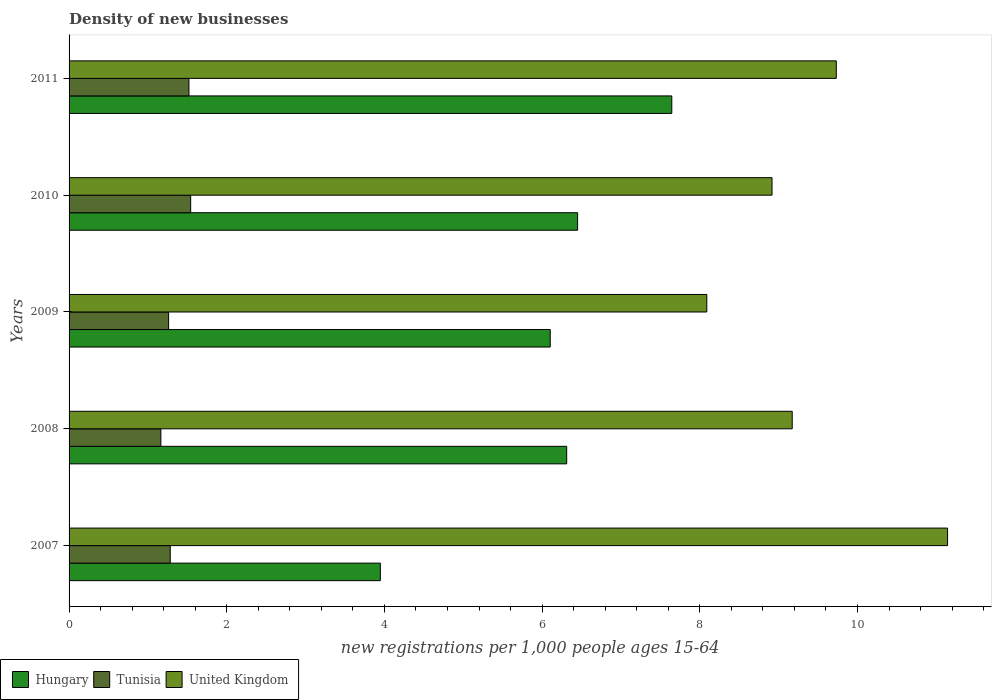How many groups of bars are there?
Provide a short and direct response. 5. Are the number of bars per tick equal to the number of legend labels?
Give a very brief answer. Yes. What is the number of new registrations in Tunisia in 2007?
Give a very brief answer. 1.28. Across all years, what is the maximum number of new registrations in United Kingdom?
Your response must be concise. 11.14. Across all years, what is the minimum number of new registrations in United Kingdom?
Ensure brevity in your answer.  8.09. In which year was the number of new registrations in Hungary maximum?
Give a very brief answer. 2011. In which year was the number of new registrations in Hungary minimum?
Keep it short and to the point. 2007. What is the total number of new registrations in Tunisia in the graph?
Make the answer very short. 6.77. What is the difference between the number of new registrations in Hungary in 2007 and that in 2010?
Offer a very short reply. -2.5. What is the difference between the number of new registrations in Hungary in 2009 and the number of new registrations in United Kingdom in 2007?
Give a very brief answer. -5.04. What is the average number of new registrations in Hungary per year?
Keep it short and to the point. 6.09. In the year 2010, what is the difference between the number of new registrations in Hungary and number of new registrations in Tunisia?
Offer a very short reply. 4.91. What is the ratio of the number of new registrations in United Kingdom in 2007 to that in 2009?
Your response must be concise. 1.38. What is the difference between the highest and the second highest number of new registrations in Hungary?
Make the answer very short. 1.19. What is the difference between the highest and the lowest number of new registrations in Tunisia?
Your answer should be very brief. 0.38. In how many years, is the number of new registrations in Hungary greater than the average number of new registrations in Hungary taken over all years?
Provide a succinct answer. 4. Is the sum of the number of new registrations in United Kingdom in 2008 and 2009 greater than the maximum number of new registrations in Hungary across all years?
Your response must be concise. Yes. What does the 1st bar from the top in 2008 represents?
Offer a terse response. United Kingdom. What does the 3rd bar from the bottom in 2007 represents?
Your response must be concise. United Kingdom. How many bars are there?
Keep it short and to the point. 15. How many years are there in the graph?
Provide a succinct answer. 5. Are the values on the major ticks of X-axis written in scientific E-notation?
Offer a terse response. No. Does the graph contain any zero values?
Your response must be concise. No. How are the legend labels stacked?
Provide a succinct answer. Horizontal. What is the title of the graph?
Make the answer very short. Density of new businesses. What is the label or title of the X-axis?
Your answer should be very brief. New registrations per 1,0 people ages 15-64. What is the label or title of the Y-axis?
Give a very brief answer. Years. What is the new registrations per 1,000 people ages 15-64 of Hungary in 2007?
Provide a succinct answer. 3.95. What is the new registrations per 1,000 people ages 15-64 of Tunisia in 2007?
Keep it short and to the point. 1.28. What is the new registrations per 1,000 people ages 15-64 of United Kingdom in 2007?
Make the answer very short. 11.14. What is the new registrations per 1,000 people ages 15-64 of Hungary in 2008?
Offer a terse response. 6.31. What is the new registrations per 1,000 people ages 15-64 in Tunisia in 2008?
Offer a very short reply. 1.16. What is the new registrations per 1,000 people ages 15-64 of United Kingdom in 2008?
Offer a terse response. 9.17. What is the new registrations per 1,000 people ages 15-64 in Hungary in 2009?
Offer a terse response. 6.1. What is the new registrations per 1,000 people ages 15-64 in Tunisia in 2009?
Your answer should be very brief. 1.26. What is the new registrations per 1,000 people ages 15-64 of United Kingdom in 2009?
Offer a terse response. 8.09. What is the new registrations per 1,000 people ages 15-64 in Hungary in 2010?
Provide a short and direct response. 6.45. What is the new registrations per 1,000 people ages 15-64 of Tunisia in 2010?
Provide a succinct answer. 1.54. What is the new registrations per 1,000 people ages 15-64 of United Kingdom in 2010?
Provide a short and direct response. 8.92. What is the new registrations per 1,000 people ages 15-64 of Hungary in 2011?
Give a very brief answer. 7.64. What is the new registrations per 1,000 people ages 15-64 of Tunisia in 2011?
Your response must be concise. 1.52. What is the new registrations per 1,000 people ages 15-64 of United Kingdom in 2011?
Provide a succinct answer. 9.73. Across all years, what is the maximum new registrations per 1,000 people ages 15-64 in Hungary?
Your answer should be very brief. 7.64. Across all years, what is the maximum new registrations per 1,000 people ages 15-64 of Tunisia?
Ensure brevity in your answer.  1.54. Across all years, what is the maximum new registrations per 1,000 people ages 15-64 of United Kingdom?
Your answer should be compact. 11.14. Across all years, what is the minimum new registrations per 1,000 people ages 15-64 in Hungary?
Your response must be concise. 3.95. Across all years, what is the minimum new registrations per 1,000 people ages 15-64 in Tunisia?
Offer a terse response. 1.16. Across all years, what is the minimum new registrations per 1,000 people ages 15-64 in United Kingdom?
Your answer should be compact. 8.09. What is the total new registrations per 1,000 people ages 15-64 of Hungary in the graph?
Keep it short and to the point. 30.46. What is the total new registrations per 1,000 people ages 15-64 of Tunisia in the graph?
Your answer should be compact. 6.77. What is the total new registrations per 1,000 people ages 15-64 of United Kingdom in the graph?
Provide a succinct answer. 47.05. What is the difference between the new registrations per 1,000 people ages 15-64 of Hungary in 2007 and that in 2008?
Your answer should be compact. -2.36. What is the difference between the new registrations per 1,000 people ages 15-64 in Tunisia in 2007 and that in 2008?
Your response must be concise. 0.12. What is the difference between the new registrations per 1,000 people ages 15-64 in United Kingdom in 2007 and that in 2008?
Keep it short and to the point. 1.97. What is the difference between the new registrations per 1,000 people ages 15-64 in Hungary in 2007 and that in 2009?
Your response must be concise. -2.15. What is the difference between the new registrations per 1,000 people ages 15-64 of Tunisia in 2007 and that in 2009?
Provide a succinct answer. 0.02. What is the difference between the new registrations per 1,000 people ages 15-64 in United Kingdom in 2007 and that in 2009?
Make the answer very short. 3.05. What is the difference between the new registrations per 1,000 people ages 15-64 in Hungary in 2007 and that in 2010?
Your answer should be very brief. -2.5. What is the difference between the new registrations per 1,000 people ages 15-64 of Tunisia in 2007 and that in 2010?
Provide a succinct answer. -0.26. What is the difference between the new registrations per 1,000 people ages 15-64 in United Kingdom in 2007 and that in 2010?
Ensure brevity in your answer.  2.23. What is the difference between the new registrations per 1,000 people ages 15-64 of Hungary in 2007 and that in 2011?
Ensure brevity in your answer.  -3.7. What is the difference between the new registrations per 1,000 people ages 15-64 of Tunisia in 2007 and that in 2011?
Your answer should be compact. -0.24. What is the difference between the new registrations per 1,000 people ages 15-64 of United Kingdom in 2007 and that in 2011?
Make the answer very short. 1.41. What is the difference between the new registrations per 1,000 people ages 15-64 in Hungary in 2008 and that in 2009?
Offer a terse response. 0.21. What is the difference between the new registrations per 1,000 people ages 15-64 in Tunisia in 2008 and that in 2009?
Provide a short and direct response. -0.1. What is the difference between the new registrations per 1,000 people ages 15-64 of United Kingdom in 2008 and that in 2009?
Give a very brief answer. 1.08. What is the difference between the new registrations per 1,000 people ages 15-64 of Hungary in 2008 and that in 2010?
Give a very brief answer. -0.14. What is the difference between the new registrations per 1,000 people ages 15-64 in Tunisia in 2008 and that in 2010?
Make the answer very short. -0.38. What is the difference between the new registrations per 1,000 people ages 15-64 in United Kingdom in 2008 and that in 2010?
Give a very brief answer. 0.26. What is the difference between the new registrations per 1,000 people ages 15-64 of Hungary in 2008 and that in 2011?
Offer a very short reply. -1.33. What is the difference between the new registrations per 1,000 people ages 15-64 of Tunisia in 2008 and that in 2011?
Ensure brevity in your answer.  -0.36. What is the difference between the new registrations per 1,000 people ages 15-64 of United Kingdom in 2008 and that in 2011?
Provide a short and direct response. -0.56. What is the difference between the new registrations per 1,000 people ages 15-64 of Hungary in 2009 and that in 2010?
Offer a terse response. -0.35. What is the difference between the new registrations per 1,000 people ages 15-64 of Tunisia in 2009 and that in 2010?
Give a very brief answer. -0.28. What is the difference between the new registrations per 1,000 people ages 15-64 in United Kingdom in 2009 and that in 2010?
Make the answer very short. -0.83. What is the difference between the new registrations per 1,000 people ages 15-64 in Hungary in 2009 and that in 2011?
Ensure brevity in your answer.  -1.54. What is the difference between the new registrations per 1,000 people ages 15-64 in Tunisia in 2009 and that in 2011?
Provide a succinct answer. -0.26. What is the difference between the new registrations per 1,000 people ages 15-64 in United Kingdom in 2009 and that in 2011?
Provide a succinct answer. -1.64. What is the difference between the new registrations per 1,000 people ages 15-64 in Hungary in 2010 and that in 2011?
Provide a succinct answer. -1.19. What is the difference between the new registrations per 1,000 people ages 15-64 in Tunisia in 2010 and that in 2011?
Your answer should be very brief. 0.02. What is the difference between the new registrations per 1,000 people ages 15-64 in United Kingdom in 2010 and that in 2011?
Your answer should be very brief. -0.81. What is the difference between the new registrations per 1,000 people ages 15-64 in Hungary in 2007 and the new registrations per 1,000 people ages 15-64 in Tunisia in 2008?
Keep it short and to the point. 2.78. What is the difference between the new registrations per 1,000 people ages 15-64 of Hungary in 2007 and the new registrations per 1,000 people ages 15-64 of United Kingdom in 2008?
Your answer should be compact. -5.22. What is the difference between the new registrations per 1,000 people ages 15-64 in Tunisia in 2007 and the new registrations per 1,000 people ages 15-64 in United Kingdom in 2008?
Your response must be concise. -7.89. What is the difference between the new registrations per 1,000 people ages 15-64 of Hungary in 2007 and the new registrations per 1,000 people ages 15-64 of Tunisia in 2009?
Make the answer very short. 2.69. What is the difference between the new registrations per 1,000 people ages 15-64 of Hungary in 2007 and the new registrations per 1,000 people ages 15-64 of United Kingdom in 2009?
Provide a succinct answer. -4.14. What is the difference between the new registrations per 1,000 people ages 15-64 of Tunisia in 2007 and the new registrations per 1,000 people ages 15-64 of United Kingdom in 2009?
Make the answer very short. -6.81. What is the difference between the new registrations per 1,000 people ages 15-64 of Hungary in 2007 and the new registrations per 1,000 people ages 15-64 of Tunisia in 2010?
Your response must be concise. 2.41. What is the difference between the new registrations per 1,000 people ages 15-64 in Hungary in 2007 and the new registrations per 1,000 people ages 15-64 in United Kingdom in 2010?
Offer a terse response. -4.97. What is the difference between the new registrations per 1,000 people ages 15-64 of Tunisia in 2007 and the new registrations per 1,000 people ages 15-64 of United Kingdom in 2010?
Make the answer very short. -7.63. What is the difference between the new registrations per 1,000 people ages 15-64 of Hungary in 2007 and the new registrations per 1,000 people ages 15-64 of Tunisia in 2011?
Ensure brevity in your answer.  2.43. What is the difference between the new registrations per 1,000 people ages 15-64 in Hungary in 2007 and the new registrations per 1,000 people ages 15-64 in United Kingdom in 2011?
Provide a succinct answer. -5.78. What is the difference between the new registrations per 1,000 people ages 15-64 in Tunisia in 2007 and the new registrations per 1,000 people ages 15-64 in United Kingdom in 2011?
Offer a terse response. -8.45. What is the difference between the new registrations per 1,000 people ages 15-64 of Hungary in 2008 and the new registrations per 1,000 people ages 15-64 of Tunisia in 2009?
Your answer should be compact. 5.05. What is the difference between the new registrations per 1,000 people ages 15-64 in Hungary in 2008 and the new registrations per 1,000 people ages 15-64 in United Kingdom in 2009?
Offer a very short reply. -1.78. What is the difference between the new registrations per 1,000 people ages 15-64 in Tunisia in 2008 and the new registrations per 1,000 people ages 15-64 in United Kingdom in 2009?
Keep it short and to the point. -6.92. What is the difference between the new registrations per 1,000 people ages 15-64 of Hungary in 2008 and the new registrations per 1,000 people ages 15-64 of Tunisia in 2010?
Ensure brevity in your answer.  4.77. What is the difference between the new registrations per 1,000 people ages 15-64 in Hungary in 2008 and the new registrations per 1,000 people ages 15-64 in United Kingdom in 2010?
Offer a very short reply. -2.6. What is the difference between the new registrations per 1,000 people ages 15-64 of Tunisia in 2008 and the new registrations per 1,000 people ages 15-64 of United Kingdom in 2010?
Your answer should be very brief. -7.75. What is the difference between the new registrations per 1,000 people ages 15-64 in Hungary in 2008 and the new registrations per 1,000 people ages 15-64 in Tunisia in 2011?
Your answer should be very brief. 4.79. What is the difference between the new registrations per 1,000 people ages 15-64 in Hungary in 2008 and the new registrations per 1,000 people ages 15-64 in United Kingdom in 2011?
Your answer should be compact. -3.42. What is the difference between the new registrations per 1,000 people ages 15-64 of Tunisia in 2008 and the new registrations per 1,000 people ages 15-64 of United Kingdom in 2011?
Offer a very short reply. -8.57. What is the difference between the new registrations per 1,000 people ages 15-64 of Hungary in 2009 and the new registrations per 1,000 people ages 15-64 of Tunisia in 2010?
Give a very brief answer. 4.56. What is the difference between the new registrations per 1,000 people ages 15-64 in Hungary in 2009 and the new registrations per 1,000 people ages 15-64 in United Kingdom in 2010?
Keep it short and to the point. -2.81. What is the difference between the new registrations per 1,000 people ages 15-64 in Tunisia in 2009 and the new registrations per 1,000 people ages 15-64 in United Kingdom in 2010?
Provide a succinct answer. -7.65. What is the difference between the new registrations per 1,000 people ages 15-64 of Hungary in 2009 and the new registrations per 1,000 people ages 15-64 of Tunisia in 2011?
Keep it short and to the point. 4.58. What is the difference between the new registrations per 1,000 people ages 15-64 in Hungary in 2009 and the new registrations per 1,000 people ages 15-64 in United Kingdom in 2011?
Your response must be concise. -3.63. What is the difference between the new registrations per 1,000 people ages 15-64 in Tunisia in 2009 and the new registrations per 1,000 people ages 15-64 in United Kingdom in 2011?
Give a very brief answer. -8.47. What is the difference between the new registrations per 1,000 people ages 15-64 of Hungary in 2010 and the new registrations per 1,000 people ages 15-64 of Tunisia in 2011?
Ensure brevity in your answer.  4.93. What is the difference between the new registrations per 1,000 people ages 15-64 in Hungary in 2010 and the new registrations per 1,000 people ages 15-64 in United Kingdom in 2011?
Your answer should be very brief. -3.28. What is the difference between the new registrations per 1,000 people ages 15-64 in Tunisia in 2010 and the new registrations per 1,000 people ages 15-64 in United Kingdom in 2011?
Offer a very short reply. -8.19. What is the average new registrations per 1,000 people ages 15-64 in Hungary per year?
Keep it short and to the point. 6.09. What is the average new registrations per 1,000 people ages 15-64 of Tunisia per year?
Give a very brief answer. 1.35. What is the average new registrations per 1,000 people ages 15-64 of United Kingdom per year?
Your response must be concise. 9.41. In the year 2007, what is the difference between the new registrations per 1,000 people ages 15-64 of Hungary and new registrations per 1,000 people ages 15-64 of Tunisia?
Your answer should be very brief. 2.66. In the year 2007, what is the difference between the new registrations per 1,000 people ages 15-64 in Hungary and new registrations per 1,000 people ages 15-64 in United Kingdom?
Provide a short and direct response. -7.19. In the year 2007, what is the difference between the new registrations per 1,000 people ages 15-64 of Tunisia and new registrations per 1,000 people ages 15-64 of United Kingdom?
Your answer should be very brief. -9.86. In the year 2008, what is the difference between the new registrations per 1,000 people ages 15-64 in Hungary and new registrations per 1,000 people ages 15-64 in Tunisia?
Give a very brief answer. 5.15. In the year 2008, what is the difference between the new registrations per 1,000 people ages 15-64 of Hungary and new registrations per 1,000 people ages 15-64 of United Kingdom?
Your answer should be very brief. -2.86. In the year 2008, what is the difference between the new registrations per 1,000 people ages 15-64 in Tunisia and new registrations per 1,000 people ages 15-64 in United Kingdom?
Your answer should be compact. -8.01. In the year 2009, what is the difference between the new registrations per 1,000 people ages 15-64 of Hungary and new registrations per 1,000 people ages 15-64 of Tunisia?
Provide a succinct answer. 4.84. In the year 2009, what is the difference between the new registrations per 1,000 people ages 15-64 of Hungary and new registrations per 1,000 people ages 15-64 of United Kingdom?
Keep it short and to the point. -1.99. In the year 2009, what is the difference between the new registrations per 1,000 people ages 15-64 in Tunisia and new registrations per 1,000 people ages 15-64 in United Kingdom?
Ensure brevity in your answer.  -6.83. In the year 2010, what is the difference between the new registrations per 1,000 people ages 15-64 of Hungary and new registrations per 1,000 people ages 15-64 of Tunisia?
Provide a succinct answer. 4.91. In the year 2010, what is the difference between the new registrations per 1,000 people ages 15-64 in Hungary and new registrations per 1,000 people ages 15-64 in United Kingdom?
Your response must be concise. -2.47. In the year 2010, what is the difference between the new registrations per 1,000 people ages 15-64 in Tunisia and new registrations per 1,000 people ages 15-64 in United Kingdom?
Provide a short and direct response. -7.37. In the year 2011, what is the difference between the new registrations per 1,000 people ages 15-64 of Hungary and new registrations per 1,000 people ages 15-64 of Tunisia?
Your answer should be compact. 6.12. In the year 2011, what is the difference between the new registrations per 1,000 people ages 15-64 in Hungary and new registrations per 1,000 people ages 15-64 in United Kingdom?
Offer a terse response. -2.09. In the year 2011, what is the difference between the new registrations per 1,000 people ages 15-64 of Tunisia and new registrations per 1,000 people ages 15-64 of United Kingdom?
Make the answer very short. -8.21. What is the ratio of the new registrations per 1,000 people ages 15-64 of Hungary in 2007 to that in 2008?
Your answer should be very brief. 0.63. What is the ratio of the new registrations per 1,000 people ages 15-64 in Tunisia in 2007 to that in 2008?
Provide a succinct answer. 1.1. What is the ratio of the new registrations per 1,000 people ages 15-64 of United Kingdom in 2007 to that in 2008?
Keep it short and to the point. 1.21. What is the ratio of the new registrations per 1,000 people ages 15-64 in Hungary in 2007 to that in 2009?
Your answer should be compact. 0.65. What is the ratio of the new registrations per 1,000 people ages 15-64 of Tunisia in 2007 to that in 2009?
Your response must be concise. 1.02. What is the ratio of the new registrations per 1,000 people ages 15-64 of United Kingdom in 2007 to that in 2009?
Make the answer very short. 1.38. What is the ratio of the new registrations per 1,000 people ages 15-64 of Hungary in 2007 to that in 2010?
Provide a succinct answer. 0.61. What is the ratio of the new registrations per 1,000 people ages 15-64 in Tunisia in 2007 to that in 2010?
Provide a succinct answer. 0.83. What is the ratio of the new registrations per 1,000 people ages 15-64 in United Kingdom in 2007 to that in 2010?
Make the answer very short. 1.25. What is the ratio of the new registrations per 1,000 people ages 15-64 of Hungary in 2007 to that in 2011?
Provide a succinct answer. 0.52. What is the ratio of the new registrations per 1,000 people ages 15-64 of Tunisia in 2007 to that in 2011?
Your answer should be compact. 0.84. What is the ratio of the new registrations per 1,000 people ages 15-64 of United Kingdom in 2007 to that in 2011?
Offer a terse response. 1.15. What is the ratio of the new registrations per 1,000 people ages 15-64 of Hungary in 2008 to that in 2009?
Offer a terse response. 1.03. What is the ratio of the new registrations per 1,000 people ages 15-64 of Tunisia in 2008 to that in 2009?
Give a very brief answer. 0.92. What is the ratio of the new registrations per 1,000 people ages 15-64 in United Kingdom in 2008 to that in 2009?
Ensure brevity in your answer.  1.13. What is the ratio of the new registrations per 1,000 people ages 15-64 in Hungary in 2008 to that in 2010?
Offer a very short reply. 0.98. What is the ratio of the new registrations per 1,000 people ages 15-64 of Tunisia in 2008 to that in 2010?
Keep it short and to the point. 0.75. What is the ratio of the new registrations per 1,000 people ages 15-64 of United Kingdom in 2008 to that in 2010?
Ensure brevity in your answer.  1.03. What is the ratio of the new registrations per 1,000 people ages 15-64 of Hungary in 2008 to that in 2011?
Your answer should be very brief. 0.83. What is the ratio of the new registrations per 1,000 people ages 15-64 of Tunisia in 2008 to that in 2011?
Offer a terse response. 0.77. What is the ratio of the new registrations per 1,000 people ages 15-64 in United Kingdom in 2008 to that in 2011?
Your answer should be compact. 0.94. What is the ratio of the new registrations per 1,000 people ages 15-64 in Hungary in 2009 to that in 2010?
Offer a terse response. 0.95. What is the ratio of the new registrations per 1,000 people ages 15-64 in Tunisia in 2009 to that in 2010?
Your answer should be compact. 0.82. What is the ratio of the new registrations per 1,000 people ages 15-64 of United Kingdom in 2009 to that in 2010?
Ensure brevity in your answer.  0.91. What is the ratio of the new registrations per 1,000 people ages 15-64 of Hungary in 2009 to that in 2011?
Give a very brief answer. 0.8. What is the ratio of the new registrations per 1,000 people ages 15-64 in Tunisia in 2009 to that in 2011?
Provide a succinct answer. 0.83. What is the ratio of the new registrations per 1,000 people ages 15-64 of United Kingdom in 2009 to that in 2011?
Your response must be concise. 0.83. What is the ratio of the new registrations per 1,000 people ages 15-64 of Hungary in 2010 to that in 2011?
Make the answer very short. 0.84. What is the ratio of the new registrations per 1,000 people ages 15-64 in Tunisia in 2010 to that in 2011?
Your answer should be compact. 1.01. What is the ratio of the new registrations per 1,000 people ages 15-64 of United Kingdom in 2010 to that in 2011?
Your answer should be very brief. 0.92. What is the difference between the highest and the second highest new registrations per 1,000 people ages 15-64 in Hungary?
Your answer should be very brief. 1.19. What is the difference between the highest and the second highest new registrations per 1,000 people ages 15-64 of Tunisia?
Provide a short and direct response. 0.02. What is the difference between the highest and the second highest new registrations per 1,000 people ages 15-64 in United Kingdom?
Your answer should be very brief. 1.41. What is the difference between the highest and the lowest new registrations per 1,000 people ages 15-64 of Hungary?
Keep it short and to the point. 3.7. What is the difference between the highest and the lowest new registrations per 1,000 people ages 15-64 in Tunisia?
Offer a terse response. 0.38. What is the difference between the highest and the lowest new registrations per 1,000 people ages 15-64 of United Kingdom?
Your response must be concise. 3.05. 